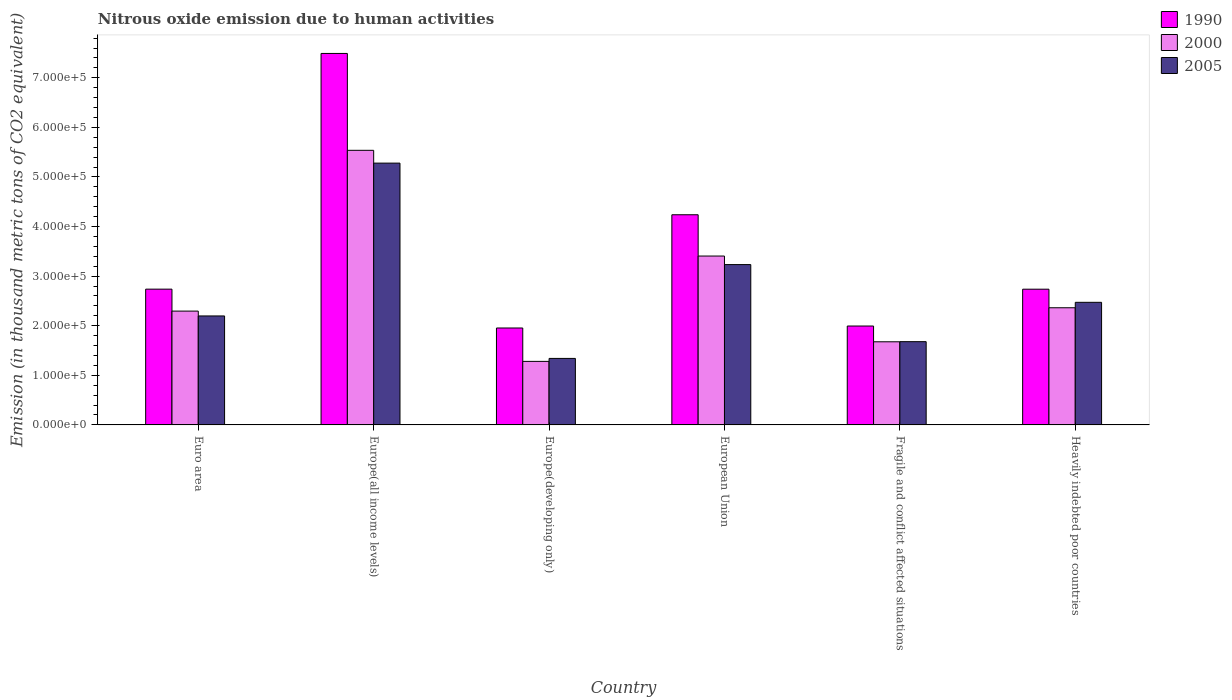How many groups of bars are there?
Your answer should be very brief. 6. Are the number of bars on each tick of the X-axis equal?
Provide a succinct answer. Yes. How many bars are there on the 1st tick from the left?
Your answer should be compact. 3. How many bars are there on the 3rd tick from the right?
Keep it short and to the point. 3. What is the label of the 2nd group of bars from the left?
Ensure brevity in your answer.  Europe(all income levels). In how many cases, is the number of bars for a given country not equal to the number of legend labels?
Provide a short and direct response. 0. What is the amount of nitrous oxide emitted in 1990 in European Union?
Offer a terse response. 4.24e+05. Across all countries, what is the maximum amount of nitrous oxide emitted in 1990?
Your answer should be compact. 7.49e+05. Across all countries, what is the minimum amount of nitrous oxide emitted in 1990?
Give a very brief answer. 1.95e+05. In which country was the amount of nitrous oxide emitted in 2000 maximum?
Provide a short and direct response. Europe(all income levels). In which country was the amount of nitrous oxide emitted in 2000 minimum?
Make the answer very short. Europe(developing only). What is the total amount of nitrous oxide emitted in 1990 in the graph?
Your answer should be very brief. 2.12e+06. What is the difference between the amount of nitrous oxide emitted in 1990 in Europe(developing only) and that in European Union?
Provide a short and direct response. -2.28e+05. What is the difference between the amount of nitrous oxide emitted in 2000 in Europe(all income levels) and the amount of nitrous oxide emitted in 1990 in Europe(developing only)?
Provide a succinct answer. 3.58e+05. What is the average amount of nitrous oxide emitted in 2000 per country?
Provide a succinct answer. 2.76e+05. What is the difference between the amount of nitrous oxide emitted of/in 1990 and amount of nitrous oxide emitted of/in 2000 in Euro area?
Your response must be concise. 4.43e+04. What is the ratio of the amount of nitrous oxide emitted in 2005 in Euro area to that in Heavily indebted poor countries?
Your response must be concise. 0.89. What is the difference between the highest and the second highest amount of nitrous oxide emitted in 2000?
Offer a terse response. -2.13e+05. What is the difference between the highest and the lowest amount of nitrous oxide emitted in 2005?
Offer a terse response. 3.94e+05. Is the sum of the amount of nitrous oxide emitted in 2005 in Euro area and Heavily indebted poor countries greater than the maximum amount of nitrous oxide emitted in 1990 across all countries?
Provide a short and direct response. No. What does the 1st bar from the right in European Union represents?
Ensure brevity in your answer.  2005. How many bars are there?
Your response must be concise. 18. Are all the bars in the graph horizontal?
Your answer should be compact. No. What is the difference between two consecutive major ticks on the Y-axis?
Offer a terse response. 1.00e+05. Does the graph contain any zero values?
Provide a short and direct response. No. Does the graph contain grids?
Keep it short and to the point. No. Where does the legend appear in the graph?
Provide a short and direct response. Top right. How many legend labels are there?
Your response must be concise. 3. How are the legend labels stacked?
Your answer should be very brief. Vertical. What is the title of the graph?
Give a very brief answer. Nitrous oxide emission due to human activities. Does "1975" appear as one of the legend labels in the graph?
Keep it short and to the point. No. What is the label or title of the X-axis?
Ensure brevity in your answer.  Country. What is the label or title of the Y-axis?
Your answer should be very brief. Emission (in thousand metric tons of CO2 equivalent). What is the Emission (in thousand metric tons of CO2 equivalent) in 1990 in Euro area?
Your answer should be very brief. 2.74e+05. What is the Emission (in thousand metric tons of CO2 equivalent) in 2000 in Euro area?
Provide a short and direct response. 2.30e+05. What is the Emission (in thousand metric tons of CO2 equivalent) of 2005 in Euro area?
Offer a terse response. 2.20e+05. What is the Emission (in thousand metric tons of CO2 equivalent) in 1990 in Europe(all income levels)?
Provide a short and direct response. 7.49e+05. What is the Emission (in thousand metric tons of CO2 equivalent) in 2000 in Europe(all income levels)?
Provide a short and direct response. 5.54e+05. What is the Emission (in thousand metric tons of CO2 equivalent) in 2005 in Europe(all income levels)?
Offer a very short reply. 5.28e+05. What is the Emission (in thousand metric tons of CO2 equivalent) of 1990 in Europe(developing only)?
Your answer should be very brief. 1.95e+05. What is the Emission (in thousand metric tons of CO2 equivalent) of 2000 in Europe(developing only)?
Your response must be concise. 1.28e+05. What is the Emission (in thousand metric tons of CO2 equivalent) in 2005 in Europe(developing only)?
Your answer should be very brief. 1.34e+05. What is the Emission (in thousand metric tons of CO2 equivalent) of 1990 in European Union?
Your response must be concise. 4.24e+05. What is the Emission (in thousand metric tons of CO2 equivalent) in 2000 in European Union?
Your response must be concise. 3.41e+05. What is the Emission (in thousand metric tons of CO2 equivalent) in 2005 in European Union?
Your answer should be very brief. 3.23e+05. What is the Emission (in thousand metric tons of CO2 equivalent) of 1990 in Fragile and conflict affected situations?
Offer a terse response. 1.99e+05. What is the Emission (in thousand metric tons of CO2 equivalent) in 2000 in Fragile and conflict affected situations?
Give a very brief answer. 1.68e+05. What is the Emission (in thousand metric tons of CO2 equivalent) in 2005 in Fragile and conflict affected situations?
Give a very brief answer. 1.68e+05. What is the Emission (in thousand metric tons of CO2 equivalent) of 1990 in Heavily indebted poor countries?
Provide a succinct answer. 2.74e+05. What is the Emission (in thousand metric tons of CO2 equivalent) of 2000 in Heavily indebted poor countries?
Provide a short and direct response. 2.36e+05. What is the Emission (in thousand metric tons of CO2 equivalent) of 2005 in Heavily indebted poor countries?
Ensure brevity in your answer.  2.47e+05. Across all countries, what is the maximum Emission (in thousand metric tons of CO2 equivalent) in 1990?
Provide a short and direct response. 7.49e+05. Across all countries, what is the maximum Emission (in thousand metric tons of CO2 equivalent) in 2000?
Ensure brevity in your answer.  5.54e+05. Across all countries, what is the maximum Emission (in thousand metric tons of CO2 equivalent) of 2005?
Offer a terse response. 5.28e+05. Across all countries, what is the minimum Emission (in thousand metric tons of CO2 equivalent) in 1990?
Give a very brief answer. 1.95e+05. Across all countries, what is the minimum Emission (in thousand metric tons of CO2 equivalent) of 2000?
Give a very brief answer. 1.28e+05. Across all countries, what is the minimum Emission (in thousand metric tons of CO2 equivalent) in 2005?
Offer a terse response. 1.34e+05. What is the total Emission (in thousand metric tons of CO2 equivalent) of 1990 in the graph?
Ensure brevity in your answer.  2.12e+06. What is the total Emission (in thousand metric tons of CO2 equivalent) in 2000 in the graph?
Your response must be concise. 1.66e+06. What is the total Emission (in thousand metric tons of CO2 equivalent) of 2005 in the graph?
Your answer should be compact. 1.62e+06. What is the difference between the Emission (in thousand metric tons of CO2 equivalent) in 1990 in Euro area and that in Europe(all income levels)?
Your answer should be very brief. -4.75e+05. What is the difference between the Emission (in thousand metric tons of CO2 equivalent) of 2000 in Euro area and that in Europe(all income levels)?
Your answer should be compact. -3.24e+05. What is the difference between the Emission (in thousand metric tons of CO2 equivalent) in 2005 in Euro area and that in Europe(all income levels)?
Your answer should be very brief. -3.08e+05. What is the difference between the Emission (in thousand metric tons of CO2 equivalent) of 1990 in Euro area and that in Europe(developing only)?
Provide a succinct answer. 7.83e+04. What is the difference between the Emission (in thousand metric tons of CO2 equivalent) in 2000 in Euro area and that in Europe(developing only)?
Your response must be concise. 1.01e+05. What is the difference between the Emission (in thousand metric tons of CO2 equivalent) of 2005 in Euro area and that in Europe(developing only)?
Your answer should be very brief. 8.57e+04. What is the difference between the Emission (in thousand metric tons of CO2 equivalent) of 1990 in Euro area and that in European Union?
Make the answer very short. -1.50e+05. What is the difference between the Emission (in thousand metric tons of CO2 equivalent) of 2000 in Euro area and that in European Union?
Offer a terse response. -1.11e+05. What is the difference between the Emission (in thousand metric tons of CO2 equivalent) in 2005 in Euro area and that in European Union?
Ensure brevity in your answer.  -1.04e+05. What is the difference between the Emission (in thousand metric tons of CO2 equivalent) of 1990 in Euro area and that in Fragile and conflict affected situations?
Your answer should be very brief. 7.44e+04. What is the difference between the Emission (in thousand metric tons of CO2 equivalent) of 2000 in Euro area and that in Fragile and conflict affected situations?
Make the answer very short. 6.19e+04. What is the difference between the Emission (in thousand metric tons of CO2 equivalent) in 2005 in Euro area and that in Fragile and conflict affected situations?
Give a very brief answer. 5.19e+04. What is the difference between the Emission (in thousand metric tons of CO2 equivalent) in 1990 in Euro area and that in Heavily indebted poor countries?
Keep it short and to the point. 95.3. What is the difference between the Emission (in thousand metric tons of CO2 equivalent) in 2000 in Euro area and that in Heavily indebted poor countries?
Offer a terse response. -6738.9. What is the difference between the Emission (in thousand metric tons of CO2 equivalent) in 2005 in Euro area and that in Heavily indebted poor countries?
Keep it short and to the point. -2.75e+04. What is the difference between the Emission (in thousand metric tons of CO2 equivalent) of 1990 in Europe(all income levels) and that in Europe(developing only)?
Your answer should be compact. 5.54e+05. What is the difference between the Emission (in thousand metric tons of CO2 equivalent) in 2000 in Europe(all income levels) and that in Europe(developing only)?
Offer a terse response. 4.26e+05. What is the difference between the Emission (in thousand metric tons of CO2 equivalent) in 2005 in Europe(all income levels) and that in Europe(developing only)?
Your response must be concise. 3.94e+05. What is the difference between the Emission (in thousand metric tons of CO2 equivalent) of 1990 in Europe(all income levels) and that in European Union?
Your answer should be compact. 3.25e+05. What is the difference between the Emission (in thousand metric tons of CO2 equivalent) of 2000 in Europe(all income levels) and that in European Union?
Your answer should be compact. 2.13e+05. What is the difference between the Emission (in thousand metric tons of CO2 equivalent) of 2005 in Europe(all income levels) and that in European Union?
Your answer should be compact. 2.05e+05. What is the difference between the Emission (in thousand metric tons of CO2 equivalent) of 1990 in Europe(all income levels) and that in Fragile and conflict affected situations?
Your answer should be very brief. 5.50e+05. What is the difference between the Emission (in thousand metric tons of CO2 equivalent) in 2000 in Europe(all income levels) and that in Fragile and conflict affected situations?
Keep it short and to the point. 3.86e+05. What is the difference between the Emission (in thousand metric tons of CO2 equivalent) in 2005 in Europe(all income levels) and that in Fragile and conflict affected situations?
Your answer should be compact. 3.60e+05. What is the difference between the Emission (in thousand metric tons of CO2 equivalent) of 1990 in Europe(all income levels) and that in Heavily indebted poor countries?
Keep it short and to the point. 4.75e+05. What is the difference between the Emission (in thousand metric tons of CO2 equivalent) in 2000 in Europe(all income levels) and that in Heavily indebted poor countries?
Offer a terse response. 3.18e+05. What is the difference between the Emission (in thousand metric tons of CO2 equivalent) in 2005 in Europe(all income levels) and that in Heavily indebted poor countries?
Provide a succinct answer. 2.81e+05. What is the difference between the Emission (in thousand metric tons of CO2 equivalent) in 1990 in Europe(developing only) and that in European Union?
Offer a terse response. -2.28e+05. What is the difference between the Emission (in thousand metric tons of CO2 equivalent) of 2000 in Europe(developing only) and that in European Union?
Provide a short and direct response. -2.12e+05. What is the difference between the Emission (in thousand metric tons of CO2 equivalent) in 2005 in Europe(developing only) and that in European Union?
Provide a short and direct response. -1.89e+05. What is the difference between the Emission (in thousand metric tons of CO2 equivalent) in 1990 in Europe(developing only) and that in Fragile and conflict affected situations?
Your response must be concise. -3969.9. What is the difference between the Emission (in thousand metric tons of CO2 equivalent) of 2000 in Europe(developing only) and that in Fragile and conflict affected situations?
Offer a very short reply. -3.95e+04. What is the difference between the Emission (in thousand metric tons of CO2 equivalent) in 2005 in Europe(developing only) and that in Fragile and conflict affected situations?
Provide a succinct answer. -3.38e+04. What is the difference between the Emission (in thousand metric tons of CO2 equivalent) in 1990 in Europe(developing only) and that in Heavily indebted poor countries?
Give a very brief answer. -7.82e+04. What is the difference between the Emission (in thousand metric tons of CO2 equivalent) in 2000 in Europe(developing only) and that in Heavily indebted poor countries?
Provide a succinct answer. -1.08e+05. What is the difference between the Emission (in thousand metric tons of CO2 equivalent) of 2005 in Europe(developing only) and that in Heavily indebted poor countries?
Ensure brevity in your answer.  -1.13e+05. What is the difference between the Emission (in thousand metric tons of CO2 equivalent) in 1990 in European Union and that in Fragile and conflict affected situations?
Offer a terse response. 2.24e+05. What is the difference between the Emission (in thousand metric tons of CO2 equivalent) in 2000 in European Union and that in Fragile and conflict affected situations?
Provide a short and direct response. 1.73e+05. What is the difference between the Emission (in thousand metric tons of CO2 equivalent) of 2005 in European Union and that in Fragile and conflict affected situations?
Your response must be concise. 1.55e+05. What is the difference between the Emission (in thousand metric tons of CO2 equivalent) in 1990 in European Union and that in Heavily indebted poor countries?
Your response must be concise. 1.50e+05. What is the difference between the Emission (in thousand metric tons of CO2 equivalent) of 2000 in European Union and that in Heavily indebted poor countries?
Ensure brevity in your answer.  1.04e+05. What is the difference between the Emission (in thousand metric tons of CO2 equivalent) of 2005 in European Union and that in Heavily indebted poor countries?
Offer a terse response. 7.61e+04. What is the difference between the Emission (in thousand metric tons of CO2 equivalent) in 1990 in Fragile and conflict affected situations and that in Heavily indebted poor countries?
Give a very brief answer. -7.43e+04. What is the difference between the Emission (in thousand metric tons of CO2 equivalent) of 2000 in Fragile and conflict affected situations and that in Heavily indebted poor countries?
Your answer should be very brief. -6.86e+04. What is the difference between the Emission (in thousand metric tons of CO2 equivalent) of 2005 in Fragile and conflict affected situations and that in Heavily indebted poor countries?
Keep it short and to the point. -7.94e+04. What is the difference between the Emission (in thousand metric tons of CO2 equivalent) in 1990 in Euro area and the Emission (in thousand metric tons of CO2 equivalent) in 2000 in Europe(all income levels)?
Give a very brief answer. -2.80e+05. What is the difference between the Emission (in thousand metric tons of CO2 equivalent) of 1990 in Euro area and the Emission (in thousand metric tons of CO2 equivalent) of 2005 in Europe(all income levels)?
Provide a short and direct response. -2.54e+05. What is the difference between the Emission (in thousand metric tons of CO2 equivalent) of 2000 in Euro area and the Emission (in thousand metric tons of CO2 equivalent) of 2005 in Europe(all income levels)?
Provide a succinct answer. -2.98e+05. What is the difference between the Emission (in thousand metric tons of CO2 equivalent) of 1990 in Euro area and the Emission (in thousand metric tons of CO2 equivalent) of 2000 in Europe(developing only)?
Offer a very short reply. 1.46e+05. What is the difference between the Emission (in thousand metric tons of CO2 equivalent) in 1990 in Euro area and the Emission (in thousand metric tons of CO2 equivalent) in 2005 in Europe(developing only)?
Give a very brief answer. 1.40e+05. What is the difference between the Emission (in thousand metric tons of CO2 equivalent) of 2000 in Euro area and the Emission (in thousand metric tons of CO2 equivalent) of 2005 in Europe(developing only)?
Give a very brief answer. 9.54e+04. What is the difference between the Emission (in thousand metric tons of CO2 equivalent) in 1990 in Euro area and the Emission (in thousand metric tons of CO2 equivalent) in 2000 in European Union?
Give a very brief answer. -6.68e+04. What is the difference between the Emission (in thousand metric tons of CO2 equivalent) of 1990 in Euro area and the Emission (in thousand metric tons of CO2 equivalent) of 2005 in European Union?
Offer a very short reply. -4.95e+04. What is the difference between the Emission (in thousand metric tons of CO2 equivalent) in 2000 in Euro area and the Emission (in thousand metric tons of CO2 equivalent) in 2005 in European Union?
Provide a short and direct response. -9.38e+04. What is the difference between the Emission (in thousand metric tons of CO2 equivalent) of 1990 in Euro area and the Emission (in thousand metric tons of CO2 equivalent) of 2000 in Fragile and conflict affected situations?
Provide a short and direct response. 1.06e+05. What is the difference between the Emission (in thousand metric tons of CO2 equivalent) in 1990 in Euro area and the Emission (in thousand metric tons of CO2 equivalent) in 2005 in Fragile and conflict affected situations?
Your answer should be compact. 1.06e+05. What is the difference between the Emission (in thousand metric tons of CO2 equivalent) in 2000 in Euro area and the Emission (in thousand metric tons of CO2 equivalent) in 2005 in Fragile and conflict affected situations?
Keep it short and to the point. 6.16e+04. What is the difference between the Emission (in thousand metric tons of CO2 equivalent) in 1990 in Euro area and the Emission (in thousand metric tons of CO2 equivalent) in 2000 in Heavily indebted poor countries?
Offer a very short reply. 3.75e+04. What is the difference between the Emission (in thousand metric tons of CO2 equivalent) in 1990 in Euro area and the Emission (in thousand metric tons of CO2 equivalent) in 2005 in Heavily indebted poor countries?
Offer a very short reply. 2.66e+04. What is the difference between the Emission (in thousand metric tons of CO2 equivalent) of 2000 in Euro area and the Emission (in thousand metric tons of CO2 equivalent) of 2005 in Heavily indebted poor countries?
Ensure brevity in your answer.  -1.77e+04. What is the difference between the Emission (in thousand metric tons of CO2 equivalent) of 1990 in Europe(all income levels) and the Emission (in thousand metric tons of CO2 equivalent) of 2000 in Europe(developing only)?
Your answer should be very brief. 6.21e+05. What is the difference between the Emission (in thousand metric tons of CO2 equivalent) in 1990 in Europe(all income levels) and the Emission (in thousand metric tons of CO2 equivalent) in 2005 in Europe(developing only)?
Provide a short and direct response. 6.15e+05. What is the difference between the Emission (in thousand metric tons of CO2 equivalent) of 2000 in Europe(all income levels) and the Emission (in thousand metric tons of CO2 equivalent) of 2005 in Europe(developing only)?
Offer a terse response. 4.20e+05. What is the difference between the Emission (in thousand metric tons of CO2 equivalent) in 1990 in Europe(all income levels) and the Emission (in thousand metric tons of CO2 equivalent) in 2000 in European Union?
Ensure brevity in your answer.  4.09e+05. What is the difference between the Emission (in thousand metric tons of CO2 equivalent) in 1990 in Europe(all income levels) and the Emission (in thousand metric tons of CO2 equivalent) in 2005 in European Union?
Offer a terse response. 4.26e+05. What is the difference between the Emission (in thousand metric tons of CO2 equivalent) of 2000 in Europe(all income levels) and the Emission (in thousand metric tons of CO2 equivalent) of 2005 in European Union?
Keep it short and to the point. 2.30e+05. What is the difference between the Emission (in thousand metric tons of CO2 equivalent) in 1990 in Europe(all income levels) and the Emission (in thousand metric tons of CO2 equivalent) in 2000 in Fragile and conflict affected situations?
Offer a terse response. 5.82e+05. What is the difference between the Emission (in thousand metric tons of CO2 equivalent) in 1990 in Europe(all income levels) and the Emission (in thousand metric tons of CO2 equivalent) in 2005 in Fragile and conflict affected situations?
Offer a terse response. 5.81e+05. What is the difference between the Emission (in thousand metric tons of CO2 equivalent) of 2000 in Europe(all income levels) and the Emission (in thousand metric tons of CO2 equivalent) of 2005 in Fragile and conflict affected situations?
Provide a succinct answer. 3.86e+05. What is the difference between the Emission (in thousand metric tons of CO2 equivalent) in 1990 in Europe(all income levels) and the Emission (in thousand metric tons of CO2 equivalent) in 2000 in Heavily indebted poor countries?
Offer a terse response. 5.13e+05. What is the difference between the Emission (in thousand metric tons of CO2 equivalent) of 1990 in Europe(all income levels) and the Emission (in thousand metric tons of CO2 equivalent) of 2005 in Heavily indebted poor countries?
Give a very brief answer. 5.02e+05. What is the difference between the Emission (in thousand metric tons of CO2 equivalent) in 2000 in Europe(all income levels) and the Emission (in thousand metric tons of CO2 equivalent) in 2005 in Heavily indebted poor countries?
Offer a terse response. 3.07e+05. What is the difference between the Emission (in thousand metric tons of CO2 equivalent) of 1990 in Europe(developing only) and the Emission (in thousand metric tons of CO2 equivalent) of 2000 in European Union?
Give a very brief answer. -1.45e+05. What is the difference between the Emission (in thousand metric tons of CO2 equivalent) in 1990 in Europe(developing only) and the Emission (in thousand metric tons of CO2 equivalent) in 2005 in European Union?
Keep it short and to the point. -1.28e+05. What is the difference between the Emission (in thousand metric tons of CO2 equivalent) in 2000 in Europe(developing only) and the Emission (in thousand metric tons of CO2 equivalent) in 2005 in European Union?
Your answer should be compact. -1.95e+05. What is the difference between the Emission (in thousand metric tons of CO2 equivalent) of 1990 in Europe(developing only) and the Emission (in thousand metric tons of CO2 equivalent) of 2000 in Fragile and conflict affected situations?
Give a very brief answer. 2.78e+04. What is the difference between the Emission (in thousand metric tons of CO2 equivalent) in 1990 in Europe(developing only) and the Emission (in thousand metric tons of CO2 equivalent) in 2005 in Fragile and conflict affected situations?
Make the answer very short. 2.76e+04. What is the difference between the Emission (in thousand metric tons of CO2 equivalent) of 2000 in Europe(developing only) and the Emission (in thousand metric tons of CO2 equivalent) of 2005 in Fragile and conflict affected situations?
Keep it short and to the point. -3.98e+04. What is the difference between the Emission (in thousand metric tons of CO2 equivalent) of 1990 in Europe(developing only) and the Emission (in thousand metric tons of CO2 equivalent) of 2000 in Heavily indebted poor countries?
Your answer should be compact. -4.08e+04. What is the difference between the Emission (in thousand metric tons of CO2 equivalent) of 1990 in Europe(developing only) and the Emission (in thousand metric tons of CO2 equivalent) of 2005 in Heavily indebted poor countries?
Offer a terse response. -5.18e+04. What is the difference between the Emission (in thousand metric tons of CO2 equivalent) in 2000 in Europe(developing only) and the Emission (in thousand metric tons of CO2 equivalent) in 2005 in Heavily indebted poor countries?
Provide a succinct answer. -1.19e+05. What is the difference between the Emission (in thousand metric tons of CO2 equivalent) of 1990 in European Union and the Emission (in thousand metric tons of CO2 equivalent) of 2000 in Fragile and conflict affected situations?
Offer a terse response. 2.56e+05. What is the difference between the Emission (in thousand metric tons of CO2 equivalent) of 1990 in European Union and the Emission (in thousand metric tons of CO2 equivalent) of 2005 in Fragile and conflict affected situations?
Offer a terse response. 2.56e+05. What is the difference between the Emission (in thousand metric tons of CO2 equivalent) of 2000 in European Union and the Emission (in thousand metric tons of CO2 equivalent) of 2005 in Fragile and conflict affected situations?
Your response must be concise. 1.73e+05. What is the difference between the Emission (in thousand metric tons of CO2 equivalent) of 1990 in European Union and the Emission (in thousand metric tons of CO2 equivalent) of 2000 in Heavily indebted poor countries?
Give a very brief answer. 1.88e+05. What is the difference between the Emission (in thousand metric tons of CO2 equivalent) of 1990 in European Union and the Emission (in thousand metric tons of CO2 equivalent) of 2005 in Heavily indebted poor countries?
Your response must be concise. 1.77e+05. What is the difference between the Emission (in thousand metric tons of CO2 equivalent) in 2000 in European Union and the Emission (in thousand metric tons of CO2 equivalent) in 2005 in Heavily indebted poor countries?
Your response must be concise. 9.33e+04. What is the difference between the Emission (in thousand metric tons of CO2 equivalent) in 1990 in Fragile and conflict affected situations and the Emission (in thousand metric tons of CO2 equivalent) in 2000 in Heavily indebted poor countries?
Offer a very short reply. -3.68e+04. What is the difference between the Emission (in thousand metric tons of CO2 equivalent) of 1990 in Fragile and conflict affected situations and the Emission (in thousand metric tons of CO2 equivalent) of 2005 in Heavily indebted poor countries?
Ensure brevity in your answer.  -4.78e+04. What is the difference between the Emission (in thousand metric tons of CO2 equivalent) in 2000 in Fragile and conflict affected situations and the Emission (in thousand metric tons of CO2 equivalent) in 2005 in Heavily indebted poor countries?
Make the answer very short. -7.96e+04. What is the average Emission (in thousand metric tons of CO2 equivalent) in 1990 per country?
Offer a very short reply. 3.53e+05. What is the average Emission (in thousand metric tons of CO2 equivalent) of 2000 per country?
Your answer should be compact. 2.76e+05. What is the average Emission (in thousand metric tons of CO2 equivalent) in 2005 per country?
Offer a very short reply. 2.70e+05. What is the difference between the Emission (in thousand metric tons of CO2 equivalent) in 1990 and Emission (in thousand metric tons of CO2 equivalent) in 2000 in Euro area?
Give a very brief answer. 4.43e+04. What is the difference between the Emission (in thousand metric tons of CO2 equivalent) of 1990 and Emission (in thousand metric tons of CO2 equivalent) of 2005 in Euro area?
Provide a short and direct response. 5.40e+04. What is the difference between the Emission (in thousand metric tons of CO2 equivalent) of 2000 and Emission (in thousand metric tons of CO2 equivalent) of 2005 in Euro area?
Make the answer very short. 9758.6. What is the difference between the Emission (in thousand metric tons of CO2 equivalent) in 1990 and Emission (in thousand metric tons of CO2 equivalent) in 2000 in Europe(all income levels)?
Offer a very short reply. 1.95e+05. What is the difference between the Emission (in thousand metric tons of CO2 equivalent) of 1990 and Emission (in thousand metric tons of CO2 equivalent) of 2005 in Europe(all income levels)?
Offer a terse response. 2.21e+05. What is the difference between the Emission (in thousand metric tons of CO2 equivalent) in 2000 and Emission (in thousand metric tons of CO2 equivalent) in 2005 in Europe(all income levels)?
Provide a short and direct response. 2.58e+04. What is the difference between the Emission (in thousand metric tons of CO2 equivalent) in 1990 and Emission (in thousand metric tons of CO2 equivalent) in 2000 in Europe(developing only)?
Provide a succinct answer. 6.74e+04. What is the difference between the Emission (in thousand metric tons of CO2 equivalent) of 1990 and Emission (in thousand metric tons of CO2 equivalent) of 2005 in Europe(developing only)?
Offer a very short reply. 6.14e+04. What is the difference between the Emission (in thousand metric tons of CO2 equivalent) in 2000 and Emission (in thousand metric tons of CO2 equivalent) in 2005 in Europe(developing only)?
Offer a very short reply. -5992.3. What is the difference between the Emission (in thousand metric tons of CO2 equivalent) in 1990 and Emission (in thousand metric tons of CO2 equivalent) in 2000 in European Union?
Provide a short and direct response. 8.33e+04. What is the difference between the Emission (in thousand metric tons of CO2 equivalent) of 1990 and Emission (in thousand metric tons of CO2 equivalent) of 2005 in European Union?
Your response must be concise. 1.01e+05. What is the difference between the Emission (in thousand metric tons of CO2 equivalent) of 2000 and Emission (in thousand metric tons of CO2 equivalent) of 2005 in European Union?
Provide a short and direct response. 1.72e+04. What is the difference between the Emission (in thousand metric tons of CO2 equivalent) of 1990 and Emission (in thousand metric tons of CO2 equivalent) of 2000 in Fragile and conflict affected situations?
Your answer should be compact. 3.18e+04. What is the difference between the Emission (in thousand metric tons of CO2 equivalent) in 1990 and Emission (in thousand metric tons of CO2 equivalent) in 2005 in Fragile and conflict affected situations?
Your answer should be very brief. 3.16e+04. What is the difference between the Emission (in thousand metric tons of CO2 equivalent) of 2000 and Emission (in thousand metric tons of CO2 equivalent) of 2005 in Fragile and conflict affected situations?
Provide a short and direct response. -238.1. What is the difference between the Emission (in thousand metric tons of CO2 equivalent) in 1990 and Emission (in thousand metric tons of CO2 equivalent) in 2000 in Heavily indebted poor countries?
Provide a short and direct response. 3.74e+04. What is the difference between the Emission (in thousand metric tons of CO2 equivalent) in 1990 and Emission (in thousand metric tons of CO2 equivalent) in 2005 in Heavily indebted poor countries?
Offer a very short reply. 2.65e+04. What is the difference between the Emission (in thousand metric tons of CO2 equivalent) in 2000 and Emission (in thousand metric tons of CO2 equivalent) in 2005 in Heavily indebted poor countries?
Give a very brief answer. -1.10e+04. What is the ratio of the Emission (in thousand metric tons of CO2 equivalent) of 1990 in Euro area to that in Europe(all income levels)?
Your answer should be very brief. 0.37. What is the ratio of the Emission (in thousand metric tons of CO2 equivalent) in 2000 in Euro area to that in Europe(all income levels)?
Give a very brief answer. 0.41. What is the ratio of the Emission (in thousand metric tons of CO2 equivalent) of 2005 in Euro area to that in Europe(all income levels)?
Provide a short and direct response. 0.42. What is the ratio of the Emission (in thousand metric tons of CO2 equivalent) of 1990 in Euro area to that in Europe(developing only)?
Make the answer very short. 1.4. What is the ratio of the Emission (in thousand metric tons of CO2 equivalent) of 2000 in Euro area to that in Europe(developing only)?
Provide a succinct answer. 1.79. What is the ratio of the Emission (in thousand metric tons of CO2 equivalent) of 2005 in Euro area to that in Europe(developing only)?
Provide a short and direct response. 1.64. What is the ratio of the Emission (in thousand metric tons of CO2 equivalent) of 1990 in Euro area to that in European Union?
Provide a short and direct response. 0.65. What is the ratio of the Emission (in thousand metric tons of CO2 equivalent) in 2000 in Euro area to that in European Union?
Provide a short and direct response. 0.67. What is the ratio of the Emission (in thousand metric tons of CO2 equivalent) of 2005 in Euro area to that in European Union?
Ensure brevity in your answer.  0.68. What is the ratio of the Emission (in thousand metric tons of CO2 equivalent) in 1990 in Euro area to that in Fragile and conflict affected situations?
Give a very brief answer. 1.37. What is the ratio of the Emission (in thousand metric tons of CO2 equivalent) of 2000 in Euro area to that in Fragile and conflict affected situations?
Ensure brevity in your answer.  1.37. What is the ratio of the Emission (in thousand metric tons of CO2 equivalent) in 2005 in Euro area to that in Fragile and conflict affected situations?
Your answer should be very brief. 1.31. What is the ratio of the Emission (in thousand metric tons of CO2 equivalent) in 1990 in Euro area to that in Heavily indebted poor countries?
Your response must be concise. 1. What is the ratio of the Emission (in thousand metric tons of CO2 equivalent) of 2000 in Euro area to that in Heavily indebted poor countries?
Offer a terse response. 0.97. What is the ratio of the Emission (in thousand metric tons of CO2 equivalent) in 1990 in Europe(all income levels) to that in Europe(developing only)?
Provide a succinct answer. 3.83. What is the ratio of the Emission (in thousand metric tons of CO2 equivalent) of 2000 in Europe(all income levels) to that in Europe(developing only)?
Offer a very short reply. 4.32. What is the ratio of the Emission (in thousand metric tons of CO2 equivalent) of 2005 in Europe(all income levels) to that in Europe(developing only)?
Your answer should be very brief. 3.94. What is the ratio of the Emission (in thousand metric tons of CO2 equivalent) of 1990 in Europe(all income levels) to that in European Union?
Give a very brief answer. 1.77. What is the ratio of the Emission (in thousand metric tons of CO2 equivalent) of 2000 in Europe(all income levels) to that in European Union?
Offer a very short reply. 1.63. What is the ratio of the Emission (in thousand metric tons of CO2 equivalent) of 2005 in Europe(all income levels) to that in European Union?
Give a very brief answer. 1.63. What is the ratio of the Emission (in thousand metric tons of CO2 equivalent) of 1990 in Europe(all income levels) to that in Fragile and conflict affected situations?
Make the answer very short. 3.76. What is the ratio of the Emission (in thousand metric tons of CO2 equivalent) of 2000 in Europe(all income levels) to that in Fragile and conflict affected situations?
Offer a very short reply. 3.3. What is the ratio of the Emission (in thousand metric tons of CO2 equivalent) in 2005 in Europe(all income levels) to that in Fragile and conflict affected situations?
Provide a short and direct response. 3.14. What is the ratio of the Emission (in thousand metric tons of CO2 equivalent) in 1990 in Europe(all income levels) to that in Heavily indebted poor countries?
Make the answer very short. 2.74. What is the ratio of the Emission (in thousand metric tons of CO2 equivalent) in 2000 in Europe(all income levels) to that in Heavily indebted poor countries?
Your answer should be compact. 2.34. What is the ratio of the Emission (in thousand metric tons of CO2 equivalent) in 2005 in Europe(all income levels) to that in Heavily indebted poor countries?
Provide a succinct answer. 2.14. What is the ratio of the Emission (in thousand metric tons of CO2 equivalent) of 1990 in Europe(developing only) to that in European Union?
Give a very brief answer. 0.46. What is the ratio of the Emission (in thousand metric tons of CO2 equivalent) of 2000 in Europe(developing only) to that in European Union?
Your answer should be very brief. 0.38. What is the ratio of the Emission (in thousand metric tons of CO2 equivalent) of 2005 in Europe(developing only) to that in European Union?
Give a very brief answer. 0.41. What is the ratio of the Emission (in thousand metric tons of CO2 equivalent) in 1990 in Europe(developing only) to that in Fragile and conflict affected situations?
Make the answer very short. 0.98. What is the ratio of the Emission (in thousand metric tons of CO2 equivalent) in 2000 in Europe(developing only) to that in Fragile and conflict affected situations?
Your answer should be compact. 0.76. What is the ratio of the Emission (in thousand metric tons of CO2 equivalent) in 2005 in Europe(developing only) to that in Fragile and conflict affected situations?
Give a very brief answer. 0.8. What is the ratio of the Emission (in thousand metric tons of CO2 equivalent) of 1990 in Europe(developing only) to that in Heavily indebted poor countries?
Your answer should be compact. 0.71. What is the ratio of the Emission (in thousand metric tons of CO2 equivalent) in 2000 in Europe(developing only) to that in Heavily indebted poor countries?
Provide a succinct answer. 0.54. What is the ratio of the Emission (in thousand metric tons of CO2 equivalent) in 2005 in Europe(developing only) to that in Heavily indebted poor countries?
Provide a succinct answer. 0.54. What is the ratio of the Emission (in thousand metric tons of CO2 equivalent) in 1990 in European Union to that in Fragile and conflict affected situations?
Your answer should be very brief. 2.13. What is the ratio of the Emission (in thousand metric tons of CO2 equivalent) of 2000 in European Union to that in Fragile and conflict affected situations?
Ensure brevity in your answer.  2.03. What is the ratio of the Emission (in thousand metric tons of CO2 equivalent) of 2005 in European Union to that in Fragile and conflict affected situations?
Offer a very short reply. 1.93. What is the ratio of the Emission (in thousand metric tons of CO2 equivalent) of 1990 in European Union to that in Heavily indebted poor countries?
Make the answer very short. 1.55. What is the ratio of the Emission (in thousand metric tons of CO2 equivalent) of 2000 in European Union to that in Heavily indebted poor countries?
Provide a succinct answer. 1.44. What is the ratio of the Emission (in thousand metric tons of CO2 equivalent) in 2005 in European Union to that in Heavily indebted poor countries?
Your answer should be very brief. 1.31. What is the ratio of the Emission (in thousand metric tons of CO2 equivalent) in 1990 in Fragile and conflict affected situations to that in Heavily indebted poor countries?
Offer a very short reply. 0.73. What is the ratio of the Emission (in thousand metric tons of CO2 equivalent) of 2000 in Fragile and conflict affected situations to that in Heavily indebted poor countries?
Your response must be concise. 0.71. What is the ratio of the Emission (in thousand metric tons of CO2 equivalent) in 2005 in Fragile and conflict affected situations to that in Heavily indebted poor countries?
Your answer should be compact. 0.68. What is the difference between the highest and the second highest Emission (in thousand metric tons of CO2 equivalent) in 1990?
Provide a succinct answer. 3.25e+05. What is the difference between the highest and the second highest Emission (in thousand metric tons of CO2 equivalent) of 2000?
Your answer should be compact. 2.13e+05. What is the difference between the highest and the second highest Emission (in thousand metric tons of CO2 equivalent) in 2005?
Your answer should be compact. 2.05e+05. What is the difference between the highest and the lowest Emission (in thousand metric tons of CO2 equivalent) in 1990?
Provide a short and direct response. 5.54e+05. What is the difference between the highest and the lowest Emission (in thousand metric tons of CO2 equivalent) of 2000?
Give a very brief answer. 4.26e+05. What is the difference between the highest and the lowest Emission (in thousand metric tons of CO2 equivalent) in 2005?
Make the answer very short. 3.94e+05. 